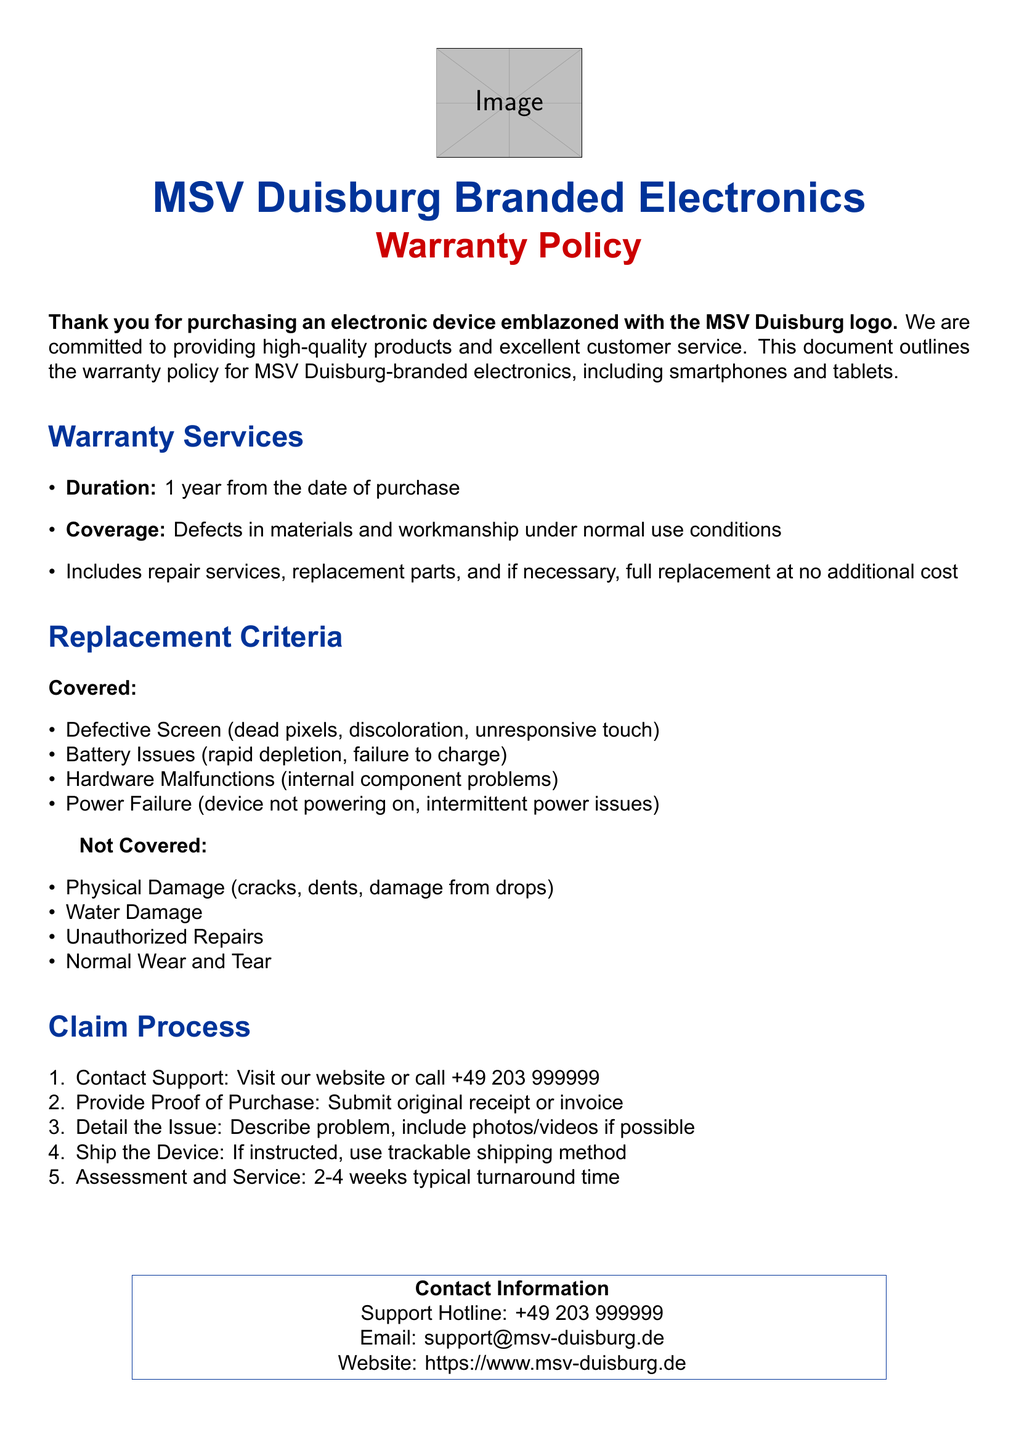what is the warranty duration for MSV Duisburg electronics? The warranty duration is specified as 1 year from the date of purchase in the document.
Answer: 1 year what types of defects are covered under warranty services? The document lists defects in materials and workmanship under normal use conditions as covered by warranty services.
Answer: Defects in materials and workmanship which battery issues are included in the replacement criteria? The document states 'rapid depletion' and 'failure to charge' as battery issues that are covered.
Answer: Rapid depletion, failure to charge what is the typical turnaround time for assessment and service? The document provides a specific timeframe for turnaround time as 2-4 weeks.
Answer: 2-4 weeks what should you provide to support when making a claim? According to the document, the proof of purchase must be submitted as part of the claim process.
Answer: Proof of purchase what happens if there is physical damage to the device? The document clearly states that physical damage is not covered under the warranty policy.
Answer: Not covered how can you contact support for warranty issues? Contact information, including phone number and email, is provided in the document for support inquiries.
Answer: +49 203 999999 what type of shipping method should be used when shipping the device? The document advises using a trackable shipping method for sending in the device for service.
Answer: Trackable shipping method 